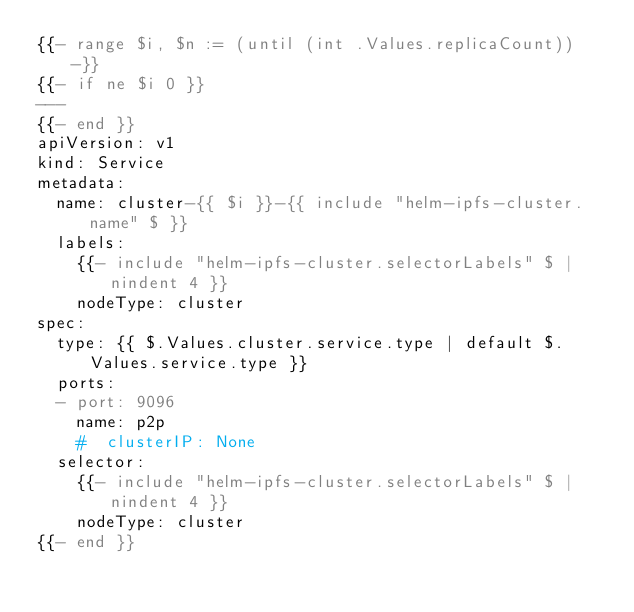<code> <loc_0><loc_0><loc_500><loc_500><_YAML_>{{- range $i, $n := (until (int .Values.replicaCount)) -}}
{{- if ne $i 0 }}
---
{{- end }}
apiVersion: v1
kind: Service
metadata:
  name: cluster-{{ $i }}-{{ include "helm-ipfs-cluster.name" $ }}
  labels:
    {{- include "helm-ipfs-cluster.selectorLabels" $ | nindent 4 }}
    nodeType: cluster
spec:
  type: {{ $.Values.cluster.service.type | default $.Values.service.type }}
  ports:
  - port: 9096
    name: p2p
    #  clusterIP: None
  selector:
    {{- include "helm-ipfs-cluster.selectorLabels" $ | nindent 4 }}
    nodeType: cluster
{{- end }}
</code> 